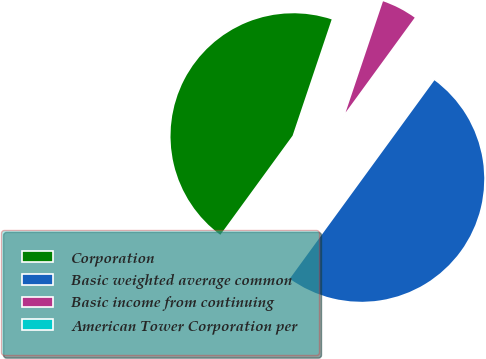Convert chart to OTSL. <chart><loc_0><loc_0><loc_500><loc_500><pie_chart><fcel>Corporation<fcel>Basic weighted average common<fcel>Basic income from continuing<fcel>American Tower Corporation per<nl><fcel>45.14%<fcel>50.0%<fcel>4.86%<fcel>0.0%<nl></chart> 